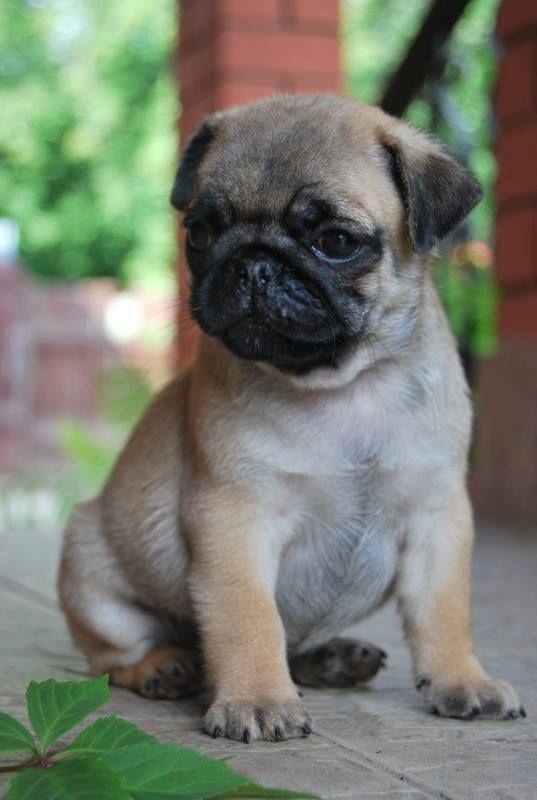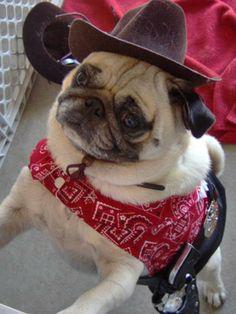The first image is the image on the left, the second image is the image on the right. For the images shown, is this caption "There is a pug wearing something decorative and cute on his head." true? Answer yes or no. Yes. The first image is the image on the left, the second image is the image on the right. Assess this claim about the two images: "At least one of the pugs is wearing something on its head.". Correct or not? Answer yes or no. Yes. 